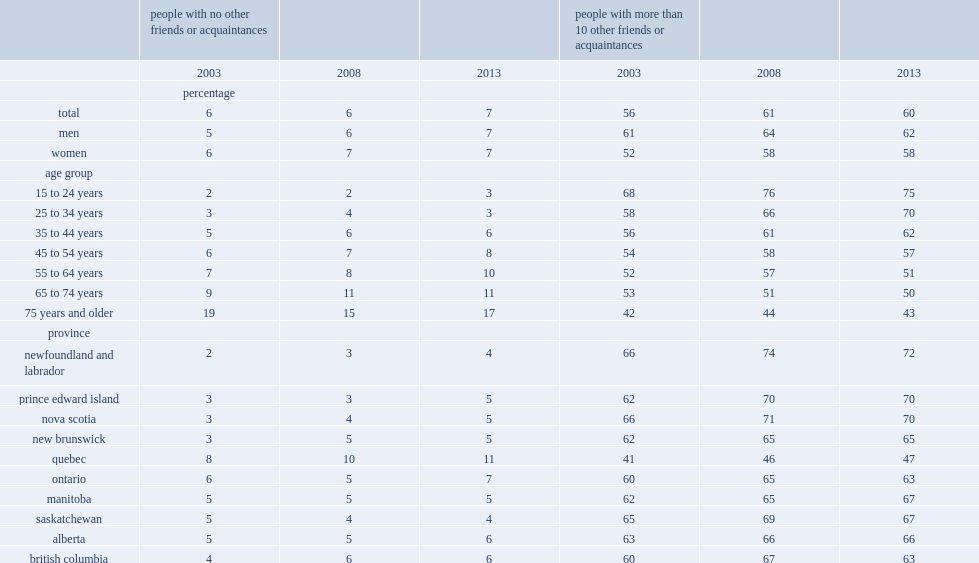What is the proportion of people with more than 10 other friends in 2003? 56.0. What is the proportion of people with more than 10 other friends in 2013? 60.0. What is the percentage of canadians aged 25 to 34 who had more than 10 'other friends' in 2003? 58.0. What is the percentage of canadians aged 25 to 34 who had more than 10 'other friends' in 2013? 70.0. 